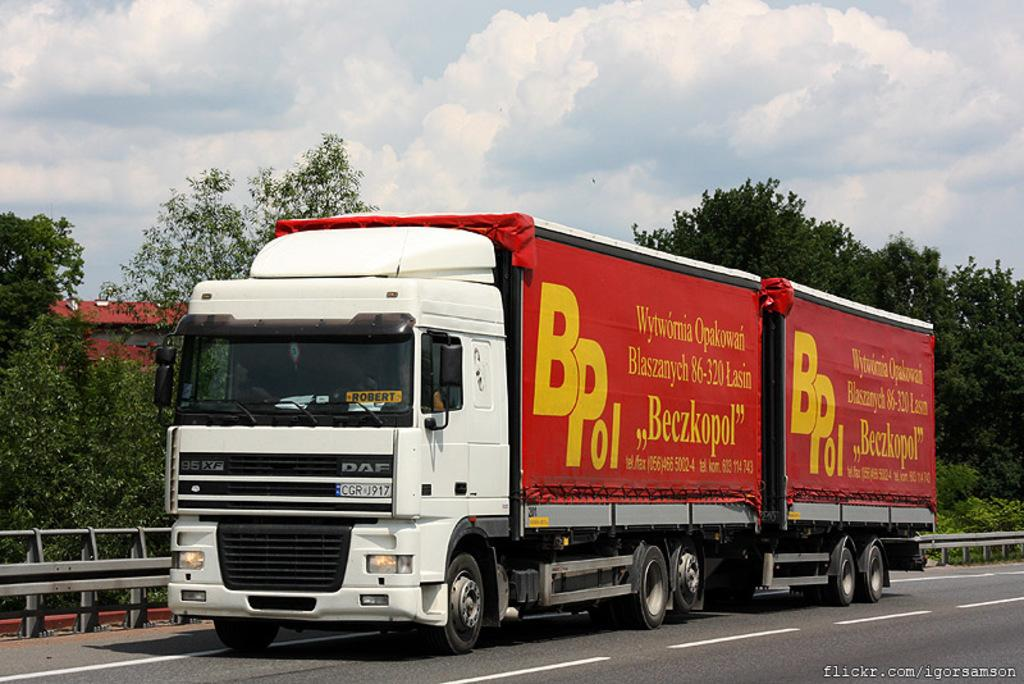What can be seen in the background of the image? The sky with clouds and trees are visible in the background of the image. What is located near the railing in the image? There is a vehicle on the road near to the railing. Is there any indication of water in the image? The bottom portion of the picture has a water mark. How does the butter affect the slope in the image? There is no butter or slope present in the image. Can you tell me how many experts are visible in the image? There are no experts visible in the image. 